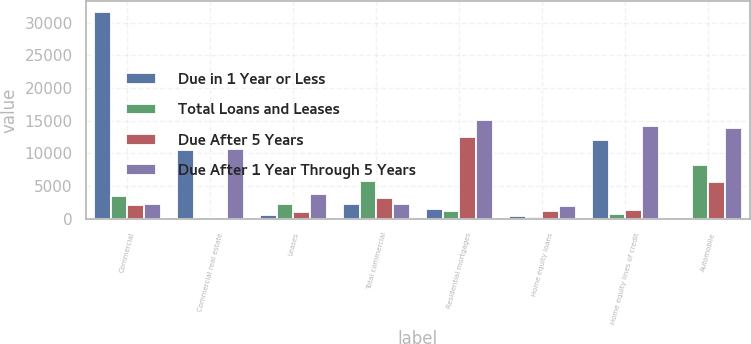Convert chart to OTSL. <chart><loc_0><loc_0><loc_500><loc_500><stacked_bar_chart><ecel><fcel>Commercial<fcel>Commercial real estate<fcel>Leases<fcel>Total commercial<fcel>Residential mortgages<fcel>Home equity loans<fcel>Home equity lines of credit<fcel>Automobile<nl><fcel>Due in 1 Year or Less<fcel>31704<fcel>10423<fcel>601<fcel>2183<fcel>1414<fcel>459<fcel>12089<fcel>131<nl><fcel>Total Loans and Leases<fcel>3508<fcel>61<fcel>2183<fcel>5752<fcel>1228<fcel>282<fcel>693<fcel>8254<nl><fcel>Due After 5 Years<fcel>2062<fcel>140<fcel>969<fcel>3171<fcel>12473<fcel>1117<fcel>1318<fcel>5553<nl><fcel>Due After 1 Year Through 5 Years<fcel>2183<fcel>10624<fcel>3753<fcel>2183<fcel>15115<fcel>1858<fcel>14100<fcel>13938<nl></chart> 